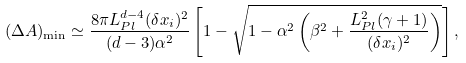Convert formula to latex. <formula><loc_0><loc_0><loc_500><loc_500>( \Delta A ) _ { \min } \simeq \frac { 8 \pi L _ { P l } ^ { d - 4 } ( \delta x _ { i } ) ^ { 2 } } { ( d - 3 ) { \alpha } ^ { 2 } } \left [ 1 - \sqrt { 1 - { \alpha } ^ { 2 } \left ( { \beta } ^ { 2 } + \frac { L _ { P l } ^ { 2 } ( \gamma + 1 ) } { ( \delta x _ { i } ) ^ { 2 } } \right ) } \right ] ,</formula> 